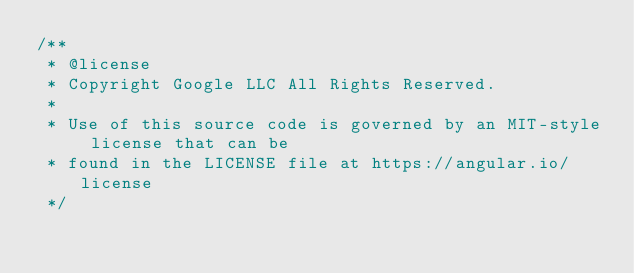<code> <loc_0><loc_0><loc_500><loc_500><_JavaScript_>/**
 * @license
 * Copyright Google LLC All Rights Reserved.
 *
 * Use of this source code is governed by an MIT-style license that can be
 * found in the LICENSE file at https://angular.io/license
 */</code> 